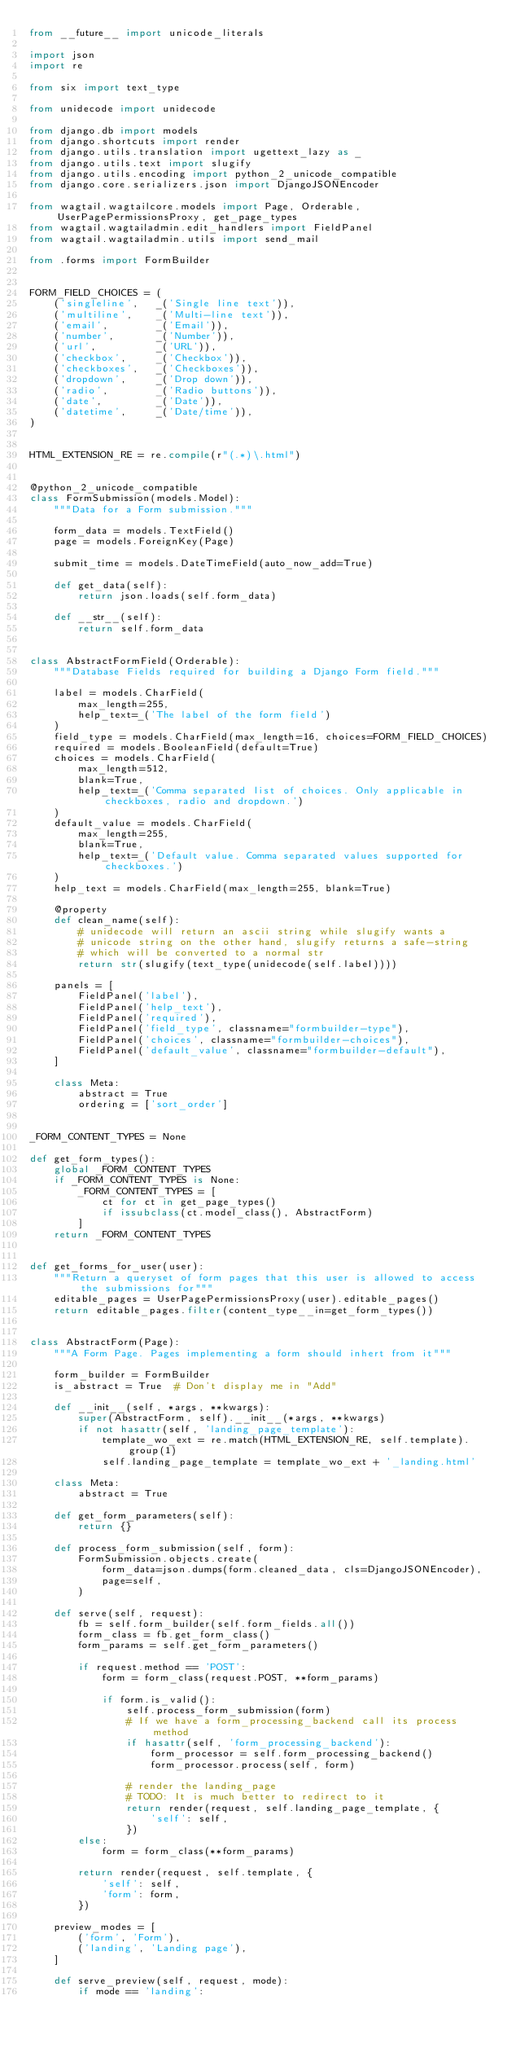<code> <loc_0><loc_0><loc_500><loc_500><_Python_>from __future__ import unicode_literals

import json
import re

from six import text_type

from unidecode import unidecode

from django.db import models
from django.shortcuts import render
from django.utils.translation import ugettext_lazy as _
from django.utils.text import slugify
from django.utils.encoding import python_2_unicode_compatible
from django.core.serializers.json import DjangoJSONEncoder

from wagtail.wagtailcore.models import Page, Orderable, UserPagePermissionsProxy, get_page_types
from wagtail.wagtailadmin.edit_handlers import FieldPanel
from wagtail.wagtailadmin.utils import send_mail

from .forms import FormBuilder


FORM_FIELD_CHOICES = (
    ('singleline',   _('Single line text')),
    ('multiline',    _('Multi-line text')),
    ('email',        _('Email')),
    ('number',       _('Number')),
    ('url',          _('URL')),
    ('checkbox',     _('Checkbox')),
    ('checkboxes',   _('Checkboxes')),
    ('dropdown',     _('Drop down')),
    ('radio',        _('Radio buttons')),
    ('date',         _('Date')),
    ('datetime',     _('Date/time')),
)


HTML_EXTENSION_RE = re.compile(r"(.*)\.html")


@python_2_unicode_compatible
class FormSubmission(models.Model):
    """Data for a Form submission."""

    form_data = models.TextField()
    page = models.ForeignKey(Page)

    submit_time = models.DateTimeField(auto_now_add=True)

    def get_data(self):
        return json.loads(self.form_data)

    def __str__(self):
        return self.form_data


class AbstractFormField(Orderable):
    """Database Fields required for building a Django Form field."""

    label = models.CharField(
        max_length=255,
        help_text=_('The label of the form field')
    )
    field_type = models.CharField(max_length=16, choices=FORM_FIELD_CHOICES)
    required = models.BooleanField(default=True)
    choices = models.CharField(
        max_length=512,
        blank=True,
        help_text=_('Comma separated list of choices. Only applicable in checkboxes, radio and dropdown.')
    )
    default_value = models.CharField(
        max_length=255,
        blank=True,
        help_text=_('Default value. Comma separated values supported for checkboxes.')
    )
    help_text = models.CharField(max_length=255, blank=True)

    @property
    def clean_name(self):
        # unidecode will return an ascii string while slugify wants a
        # unicode string on the other hand, slugify returns a safe-string
        # which will be converted to a normal str
        return str(slugify(text_type(unidecode(self.label))))

    panels = [
        FieldPanel('label'),
        FieldPanel('help_text'),
        FieldPanel('required'),
        FieldPanel('field_type', classname="formbuilder-type"),
        FieldPanel('choices', classname="formbuilder-choices"),
        FieldPanel('default_value', classname="formbuilder-default"),
    ]

    class Meta:
        abstract = True
        ordering = ['sort_order']


_FORM_CONTENT_TYPES = None

def get_form_types():
    global _FORM_CONTENT_TYPES
    if _FORM_CONTENT_TYPES is None:
        _FORM_CONTENT_TYPES = [
            ct for ct in get_page_types()
            if issubclass(ct.model_class(), AbstractForm)
        ]
    return _FORM_CONTENT_TYPES


def get_forms_for_user(user):
    """Return a queryset of form pages that this user is allowed to access the submissions for"""
    editable_pages = UserPagePermissionsProxy(user).editable_pages()
    return editable_pages.filter(content_type__in=get_form_types())


class AbstractForm(Page):
    """A Form Page. Pages implementing a form should inhert from it"""

    form_builder = FormBuilder
    is_abstract = True  # Don't display me in "Add"

    def __init__(self, *args, **kwargs):
        super(AbstractForm, self).__init__(*args, **kwargs)
        if not hasattr(self, 'landing_page_template'):
            template_wo_ext = re.match(HTML_EXTENSION_RE, self.template).group(1)
            self.landing_page_template = template_wo_ext + '_landing.html'

    class Meta:
        abstract = True

    def get_form_parameters(self):
        return {}

    def process_form_submission(self, form):
        FormSubmission.objects.create(
            form_data=json.dumps(form.cleaned_data, cls=DjangoJSONEncoder),
            page=self,
        )

    def serve(self, request):
        fb = self.form_builder(self.form_fields.all())
        form_class = fb.get_form_class()
        form_params = self.get_form_parameters()

        if request.method == 'POST':
            form = form_class(request.POST, **form_params)

            if form.is_valid():
                self.process_form_submission(form)
                # If we have a form_processing_backend call its process method
                if hasattr(self, 'form_processing_backend'):
                    form_processor = self.form_processing_backend()
                    form_processor.process(self, form)

                # render the landing_page
                # TODO: It is much better to redirect to it
                return render(request, self.landing_page_template, {
                    'self': self,
                })
        else:
            form = form_class(**form_params)

        return render(request, self.template, {
            'self': self,
            'form': form,
        })

    preview_modes = [
        ('form', 'Form'),
        ('landing', 'Landing page'),
    ]

    def serve_preview(self, request, mode):
        if mode == 'landing':</code> 